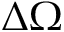Convert formula to latex. <formula><loc_0><loc_0><loc_500><loc_500>\Delta \Omega</formula> 